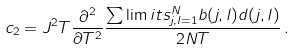Convert formula to latex. <formula><loc_0><loc_0><loc_500><loc_500>c _ { 2 } = J ^ { 2 } T \frac { \partial ^ { 2 } } { \partial T ^ { 2 } } \frac { \sum \lim i t s _ { j , l = 1 } ^ { N } b ( j , l ) d ( j , l ) } { 2 N T } \, .</formula> 